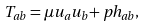<formula> <loc_0><loc_0><loc_500><loc_500>T _ { a b } = \mu u _ { a } u _ { b } + p h _ { a b } ,</formula> 